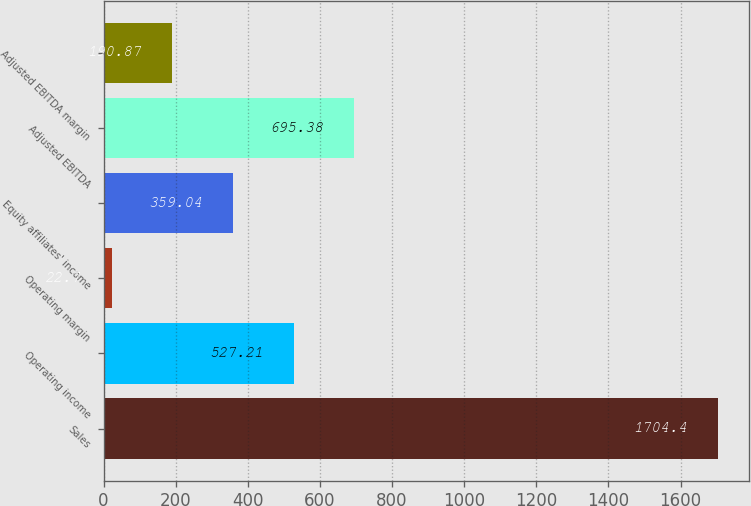<chart> <loc_0><loc_0><loc_500><loc_500><bar_chart><fcel>Sales<fcel>Operating income<fcel>Operating margin<fcel>Equity affiliates' income<fcel>Adjusted EBITDA<fcel>Adjusted EBITDA margin<nl><fcel>1704.4<fcel>527.21<fcel>22.7<fcel>359.04<fcel>695.38<fcel>190.87<nl></chart> 